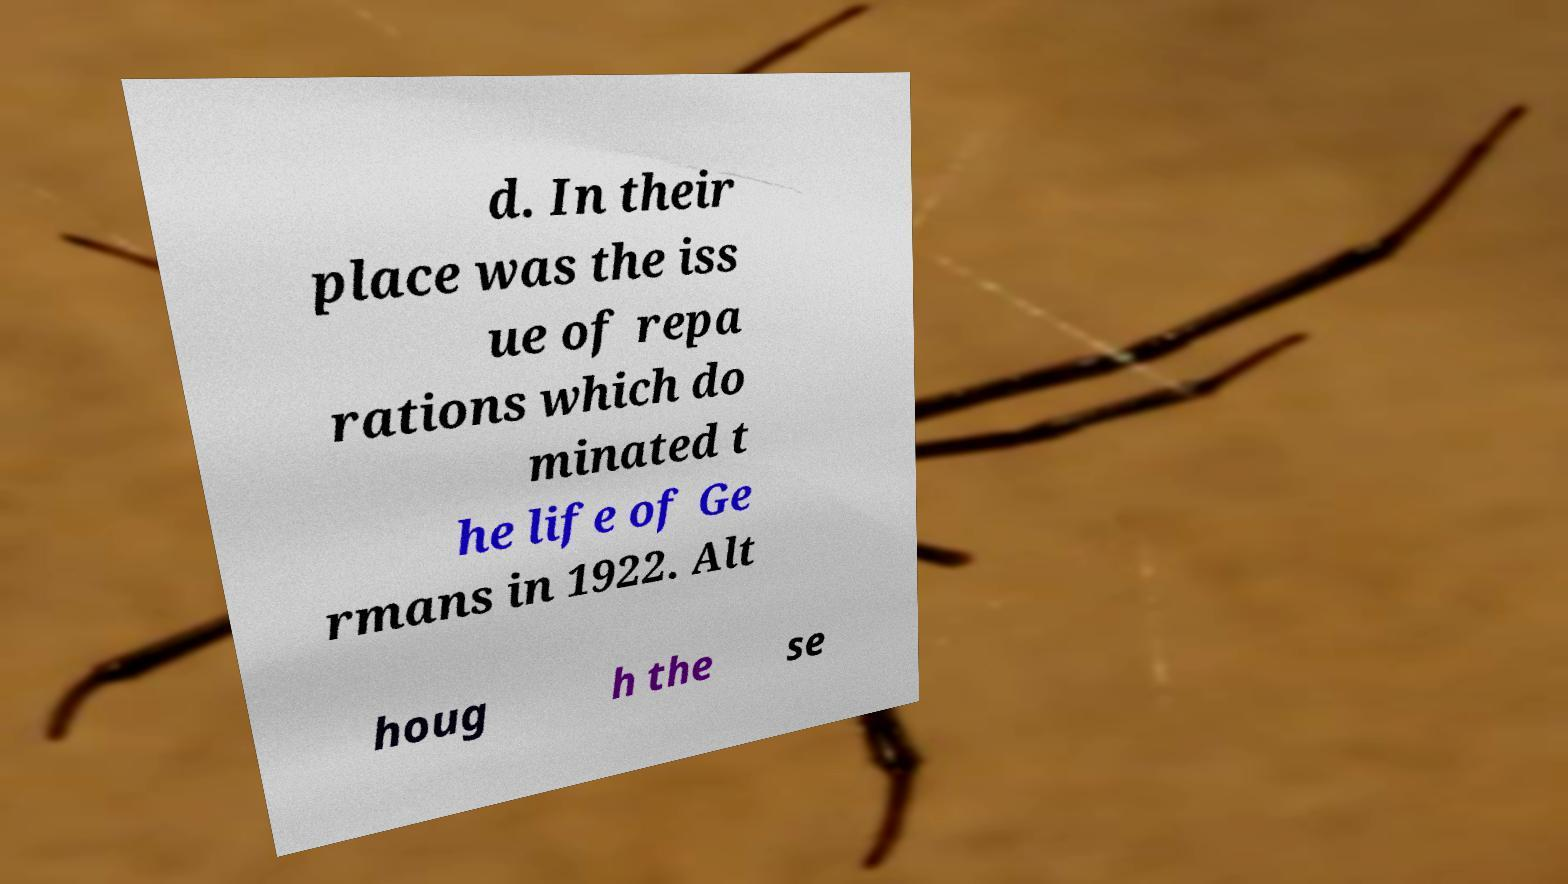What messages or text are displayed in this image? I need them in a readable, typed format. d. In their place was the iss ue of repa rations which do minated t he life of Ge rmans in 1922. Alt houg h the se 